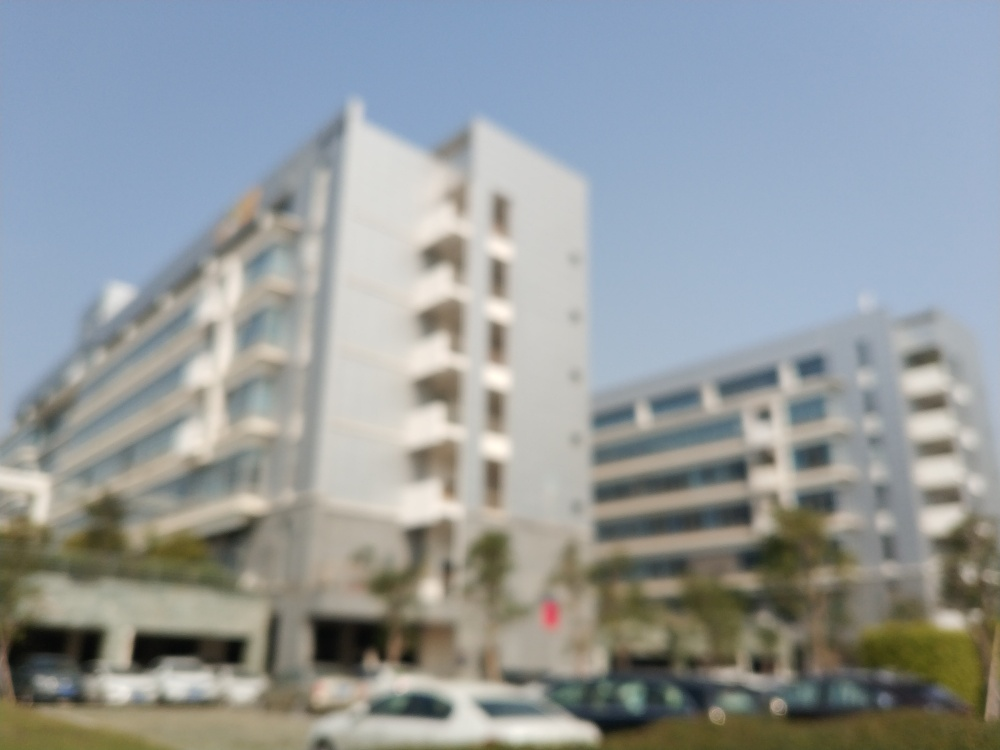Are there any unusual features in the image? The most notable feature of the image is that it is blurred, which might suggest motion or a focus issue when the picture was taken. There are no other discernible unusual details in the image. 